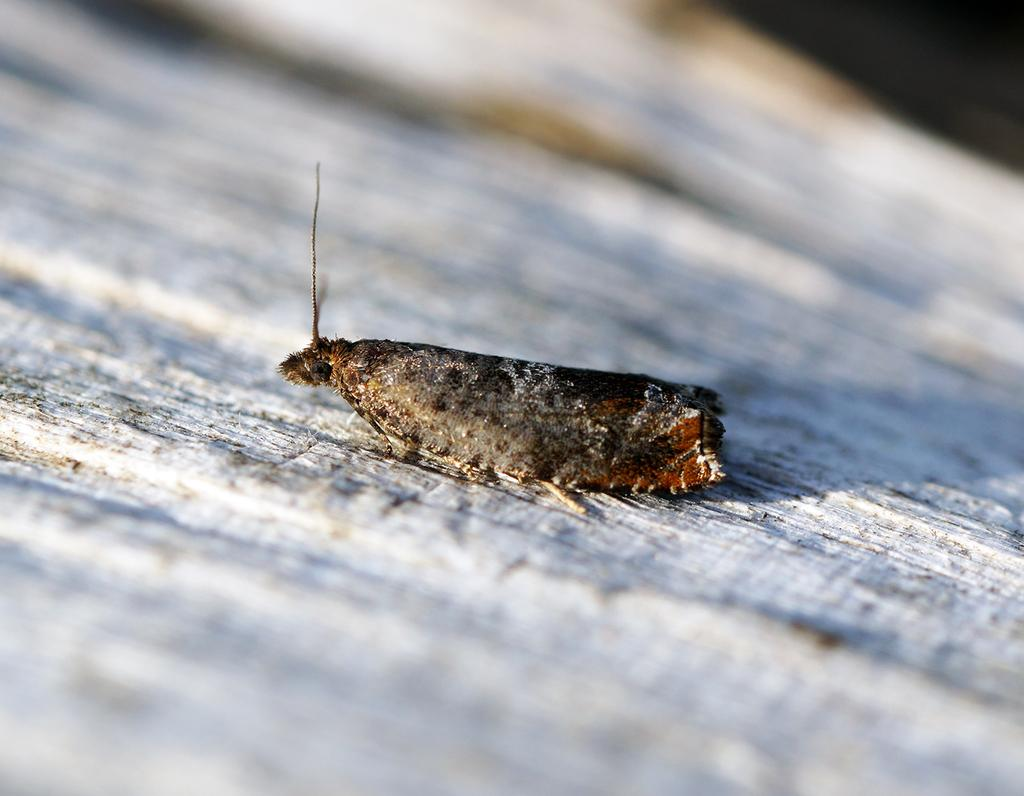What is the main subject in the center of the image? There is a moth in the center of the image. What type of haircut does the moth have in the image? There is no indication of a haircut or any hair on the moth in the image, as moths do not have hair like humans. 